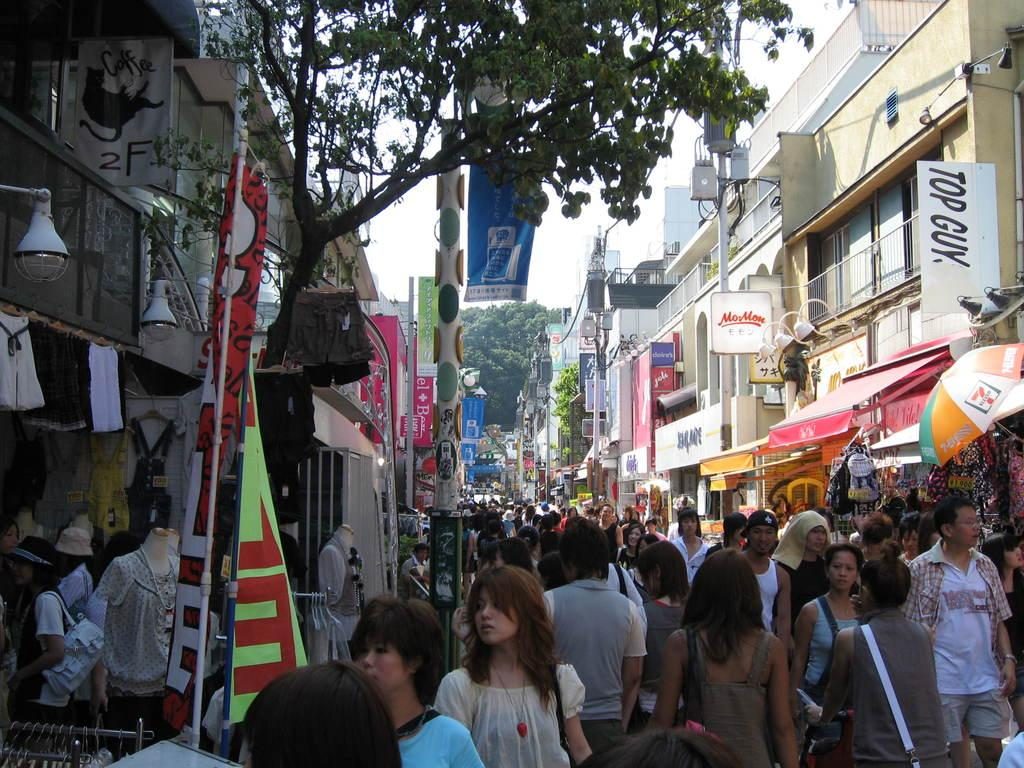What is the main feature of the image? The main feature of the image is a huge crowd. What can be seen hanging or displayed in the image? There are banners in the image. What type of structures are visible in the image? There are buildings and stores in the image. What natural element can be seen in the background of the image? There is a tree in the background of the image. What type of farming equipment can be seen in the hands of the farmer in the image? There is no farmer present in the image, so no farming equipment can be seen. What type of rock formation is visible in the image? There is no rock formation visible in the image. What type of legal proceedings are taking place in the image? There is no judge or legal proceedings depicted in the image. 